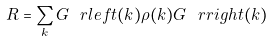Convert formula to latex. <formula><loc_0><loc_0><loc_500><loc_500>R = \sum _ { k } G _ { \ } r l e f t ( k ) \rho ( k ) G _ { \ } r r i g h t ( k )</formula> 